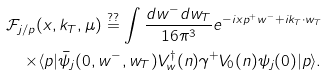<formula> <loc_0><loc_0><loc_500><loc_500>\mathcal { F } _ { j / p } ( x , { k } _ { T } , \mu ) \stackrel { ? ? } { = } \int \frac { d w ^ { - } d { w } _ { T } } { 1 6 \pi ^ { 3 } } e ^ { - i x p ^ { + } w ^ { - } + i { k } _ { T } \cdot { w } _ { T } } \\ \times \langle p | \bar { \psi } _ { j } ( 0 , w ^ { - } , { w } _ { T } ) V ^ { \dagger } _ { w } ( n ) \gamma ^ { + } V _ { 0 } ( n ) \psi _ { j } ( 0 ) | p \rangle .</formula> 